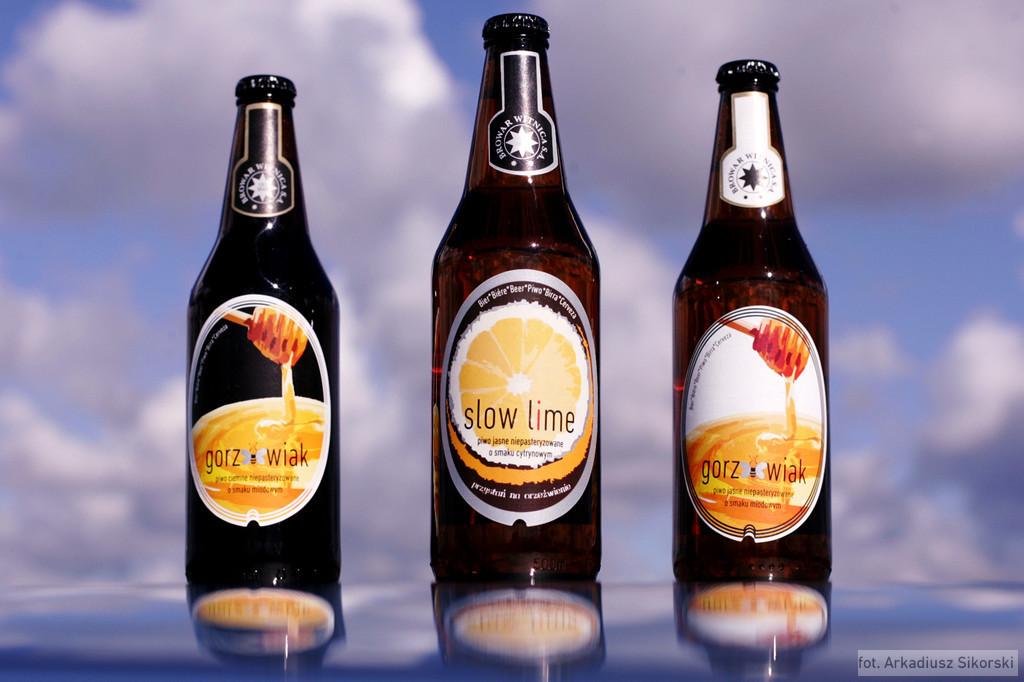What kind of beer is in the middle bottle?
Offer a terse response. Slow lime. What is the brand to the right?
Give a very brief answer. Gorz wiak. 